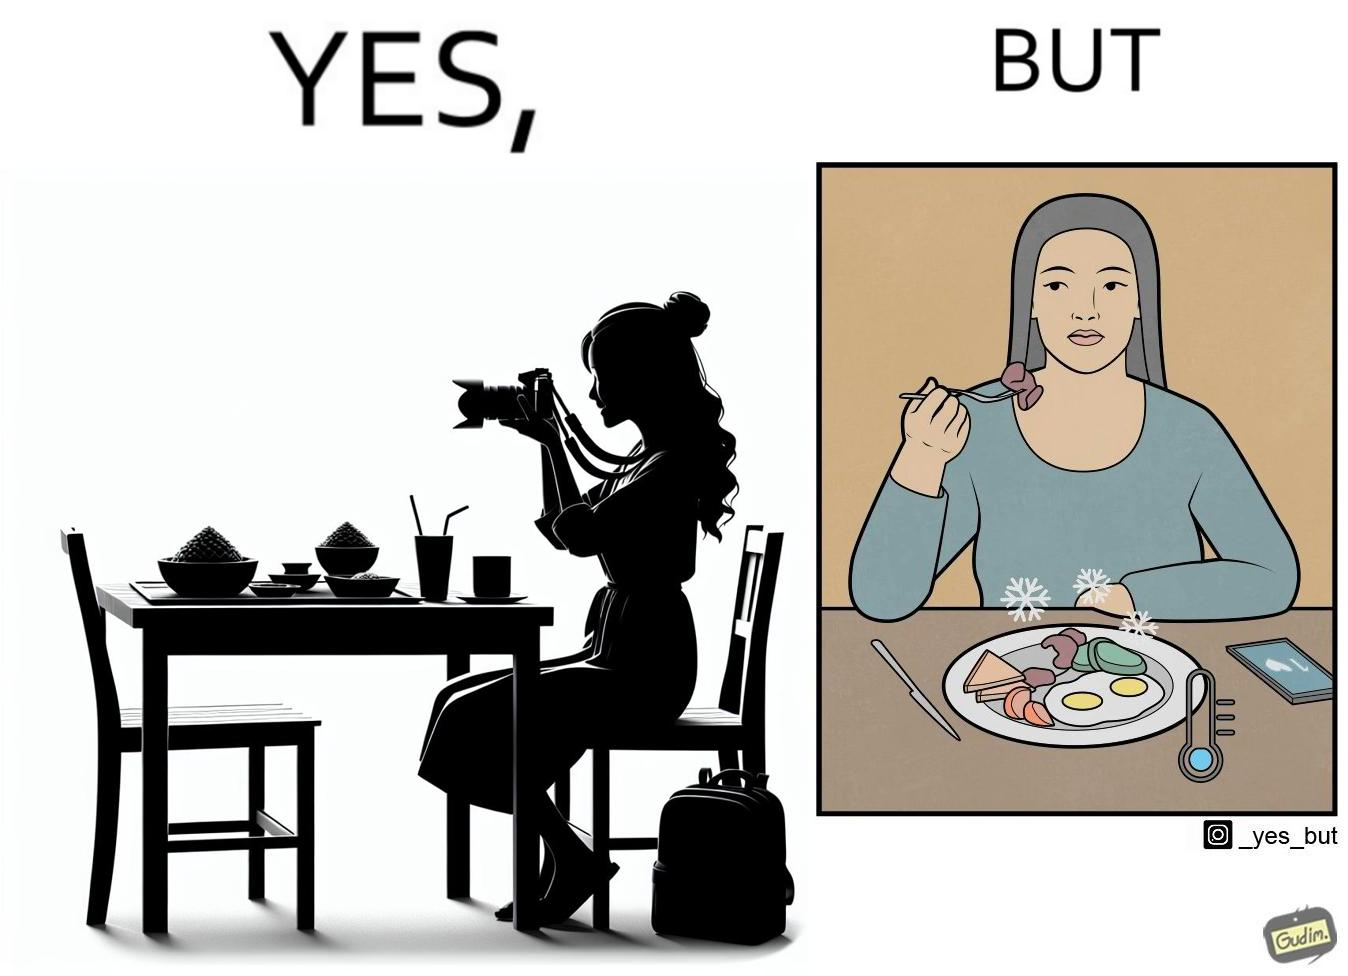What does this image depict? The images are funny since they show how a woman chooses to spend time clicking pictures of her food and by the time she is done, the food is already cold and not as appetizing as it was 